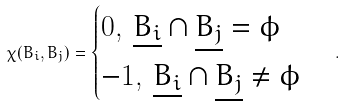Convert formula to latex. <formula><loc_0><loc_0><loc_500><loc_500>\chi ( B _ { i } , B _ { j } ) = \begin{cases} 0 , \, \underline { B _ { i } } \cap \underline { B _ { j } } = \phi \\ - 1 , \, \underline { B _ { i } } \cap \underline { B _ { j } } \ne \phi \end{cases} .</formula> 